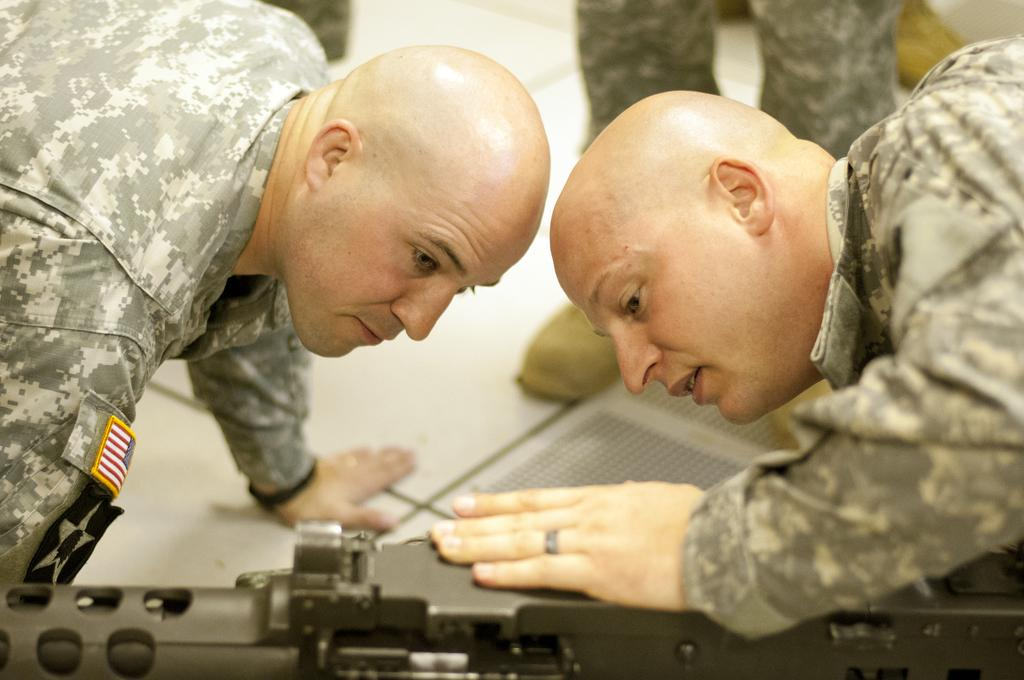How many people are in the image? There are two people in the image. What can be observed about the background in the image? The background has a blurred view. What type of surface is visible in the image? There is a floor visible in the image. What type of items are present in the image related to clothing? Clothes are present in the image. What type of items are present in the image related to footwear? Footwear is visible in the image. What color and object can be seen at the bottom of the image? There is a black color object at the bottom of the image. What type of yard can be seen in the image? There is no yard visible in the image. 